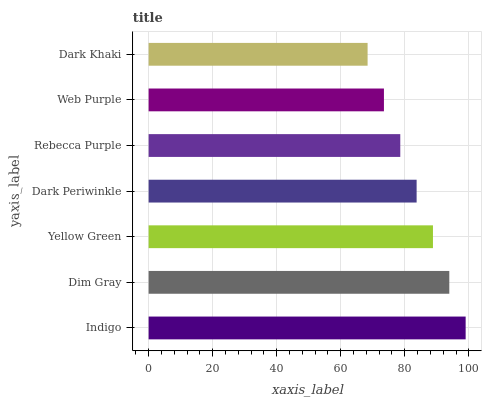Is Dark Khaki the minimum?
Answer yes or no. Yes. Is Indigo the maximum?
Answer yes or no. Yes. Is Dim Gray the minimum?
Answer yes or no. No. Is Dim Gray the maximum?
Answer yes or no. No. Is Indigo greater than Dim Gray?
Answer yes or no. Yes. Is Dim Gray less than Indigo?
Answer yes or no. Yes. Is Dim Gray greater than Indigo?
Answer yes or no. No. Is Indigo less than Dim Gray?
Answer yes or no. No. Is Dark Periwinkle the high median?
Answer yes or no. Yes. Is Dark Periwinkle the low median?
Answer yes or no. Yes. Is Rebecca Purple the high median?
Answer yes or no. No. Is Dark Khaki the low median?
Answer yes or no. No. 